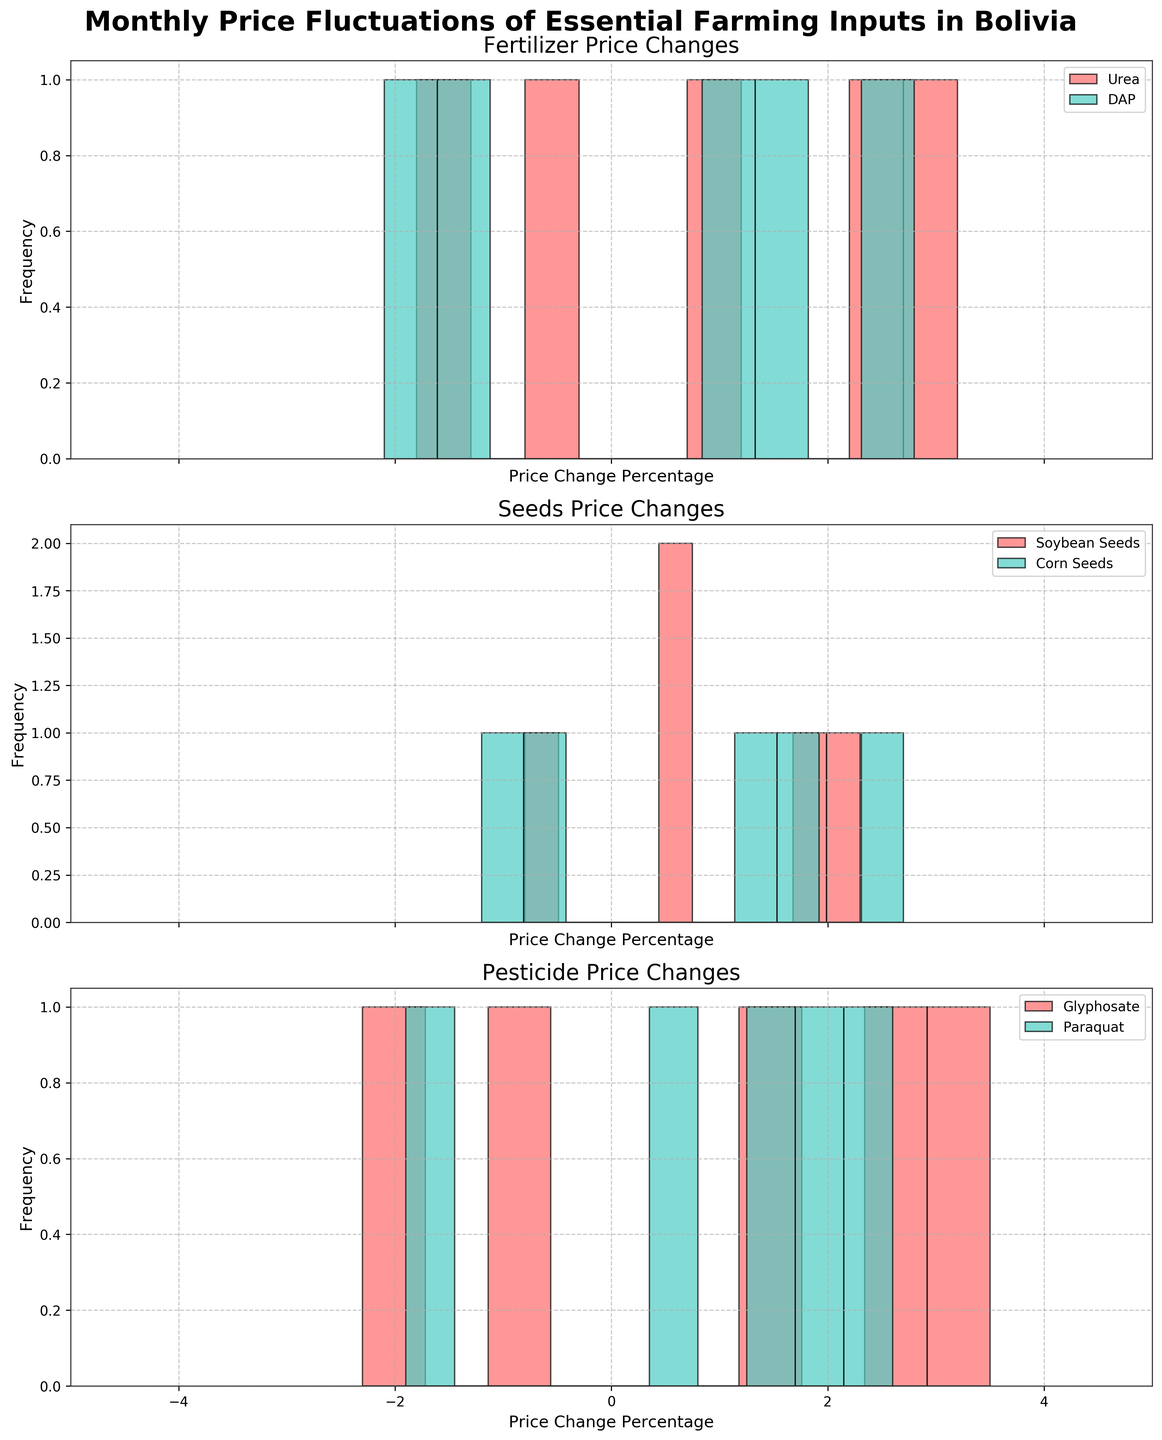Which category shows the highest price change in April? Look at the histograms for April across all categories and identify which has the highest bar for that month. For April, Glyphosate in the Pesticide category shows a price change of 2.9%, which is the highest among the categories.
Answer: Pesticide (Glyphosate, 2.9%) Which fertilizer had the highest price change in May? Locate the histogram for May within the Fertilizer subplot and identify the highest bar. For May, DAP shows the highest price change at -1.5%.
Answer: DAP (-1.5%) How many months did the price of Corn Seeds increase? Look at the histogram for Corn Seeds in each month and count the months with positive price change percentages. Corn Seeds increased in February, March, and May, which accounts for 3 months.
Answer: 3 months Compare the price changes of Soybean Seeds between February and April. Which month had a higher increase? Check the histograms for Soybean Seeds for both February and April. February shows an increase of 1.9%, and April shows an increase of 2.3%.
Answer: April (2.3%) Which product had the most frequent occurrence of price decline? Look for all negative price change values across the histograms and count their frequency for each product. Glyphosate from the Pesticide category has two occurrences of price decline (February and May). This frequency is the highest among the products.
Answer: Glyphosate What’s the average price change of fertilizers in March? Calculate the average of the price change percentages for Urea and DAP in March. The price changes are 3.2% for Urea and 2.8% for DAP. The average is (3.2 + 2.8) / 2 = 3.0%.
Answer: 3.0% Which shows more variation in price change: Urea or Paraquat? Compare the spread of the histograms for Urea and Paraquat. Urea's price changes range from -1.8% to 3.2%, while Paraquat's price changes range from -1.9% to 2.6%. Urea shows more variation in price change over the months.
Answer: Urea 